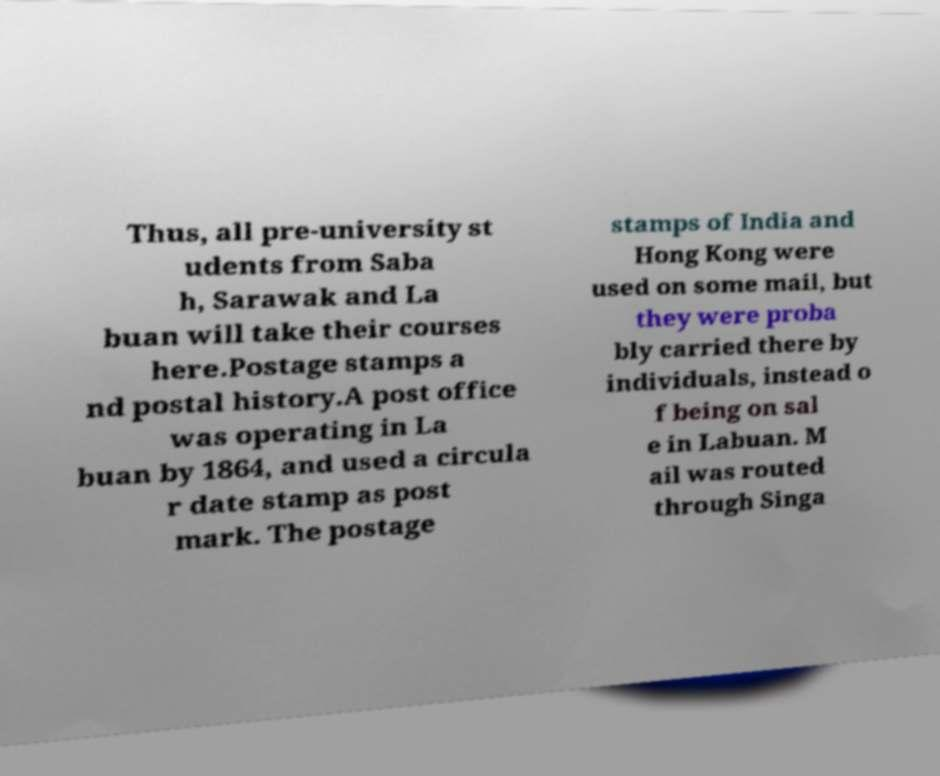Can you accurately transcribe the text from the provided image for me? Thus, all pre-university st udents from Saba h, Sarawak and La buan will take their courses here.Postage stamps a nd postal history.A post office was operating in La buan by 1864, and used a circula r date stamp as post mark. The postage stamps of India and Hong Kong were used on some mail, but they were proba bly carried there by individuals, instead o f being on sal e in Labuan. M ail was routed through Singa 